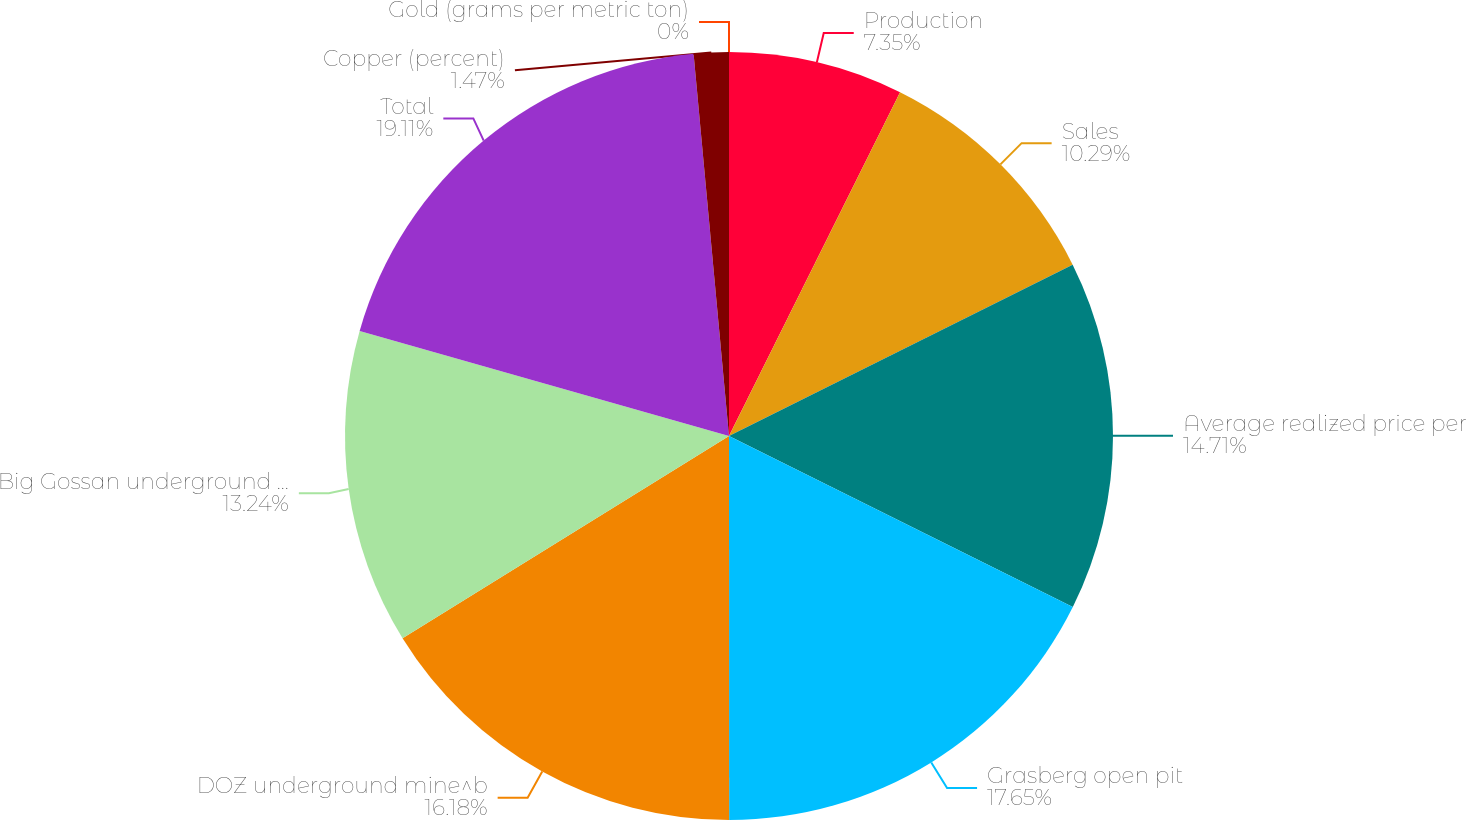Convert chart to OTSL. <chart><loc_0><loc_0><loc_500><loc_500><pie_chart><fcel>Production<fcel>Sales<fcel>Average realized price per<fcel>Grasberg open pit<fcel>DOZ underground mine^b<fcel>Big Gossan underground mine^c<fcel>Total<fcel>Copper (percent)<fcel>Gold (grams per metric ton)<nl><fcel>7.35%<fcel>10.29%<fcel>14.71%<fcel>17.65%<fcel>16.18%<fcel>13.24%<fcel>19.12%<fcel>1.47%<fcel>0.0%<nl></chart> 